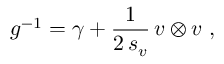<formula> <loc_0><loc_0><loc_500><loc_500>g ^ { - 1 } = \gamma + \frac { 1 } 2 \, s _ { v } } \, v \otimes v \ ,</formula> 